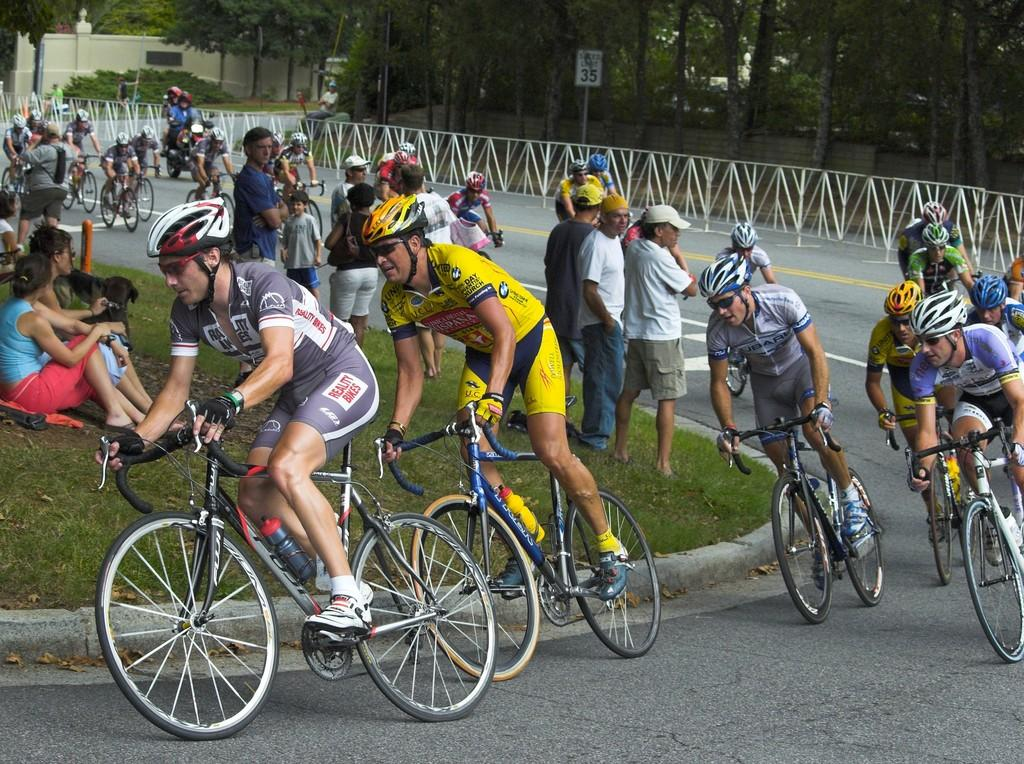What activity are the people in the image engaged in? There is a group of people riding a bicycle on a road. Are there any spectators in the image? Yes, there are people standing and sitting nearby, watching the cyclists. What error did the uncle make while riding the bicycle in the image? There is no uncle present in the image, and no errors are mentioned or depicted. 